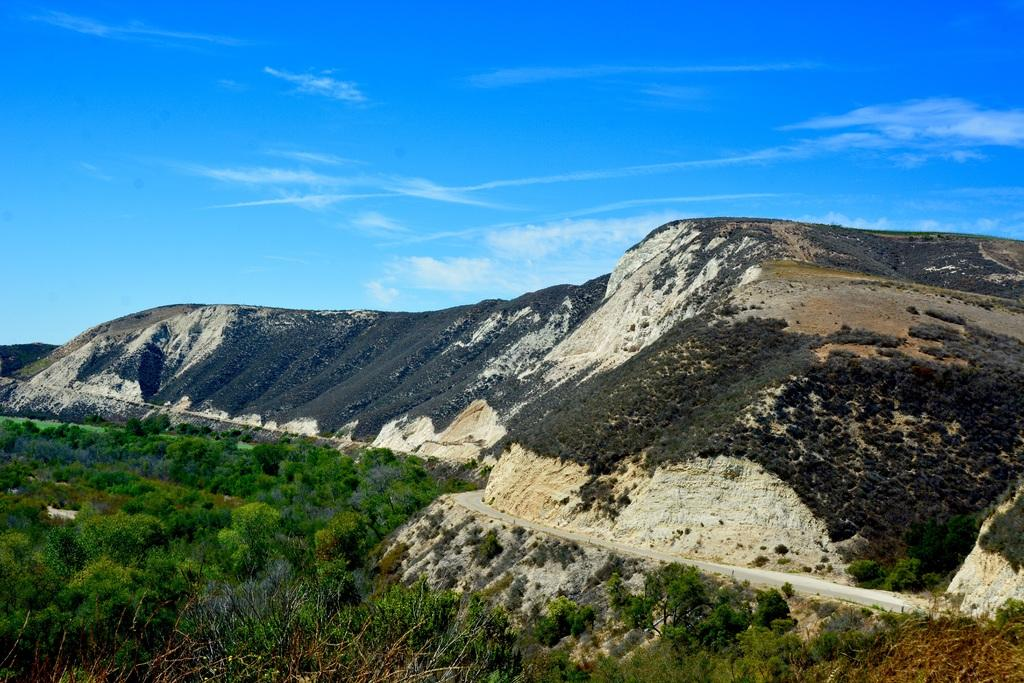What is the main feature of the image? The main feature of the image is the many plants. What else can be seen in the image besides the plants? There is a path and mountains visible in the image. How is the sky depicted in the image? The sky is blue and cloudy in the image. What type of question is being asked in the image? There is no question being asked in the image; it is a visual representation of plants, a path, mountains, and a blue and cloudy sky. 